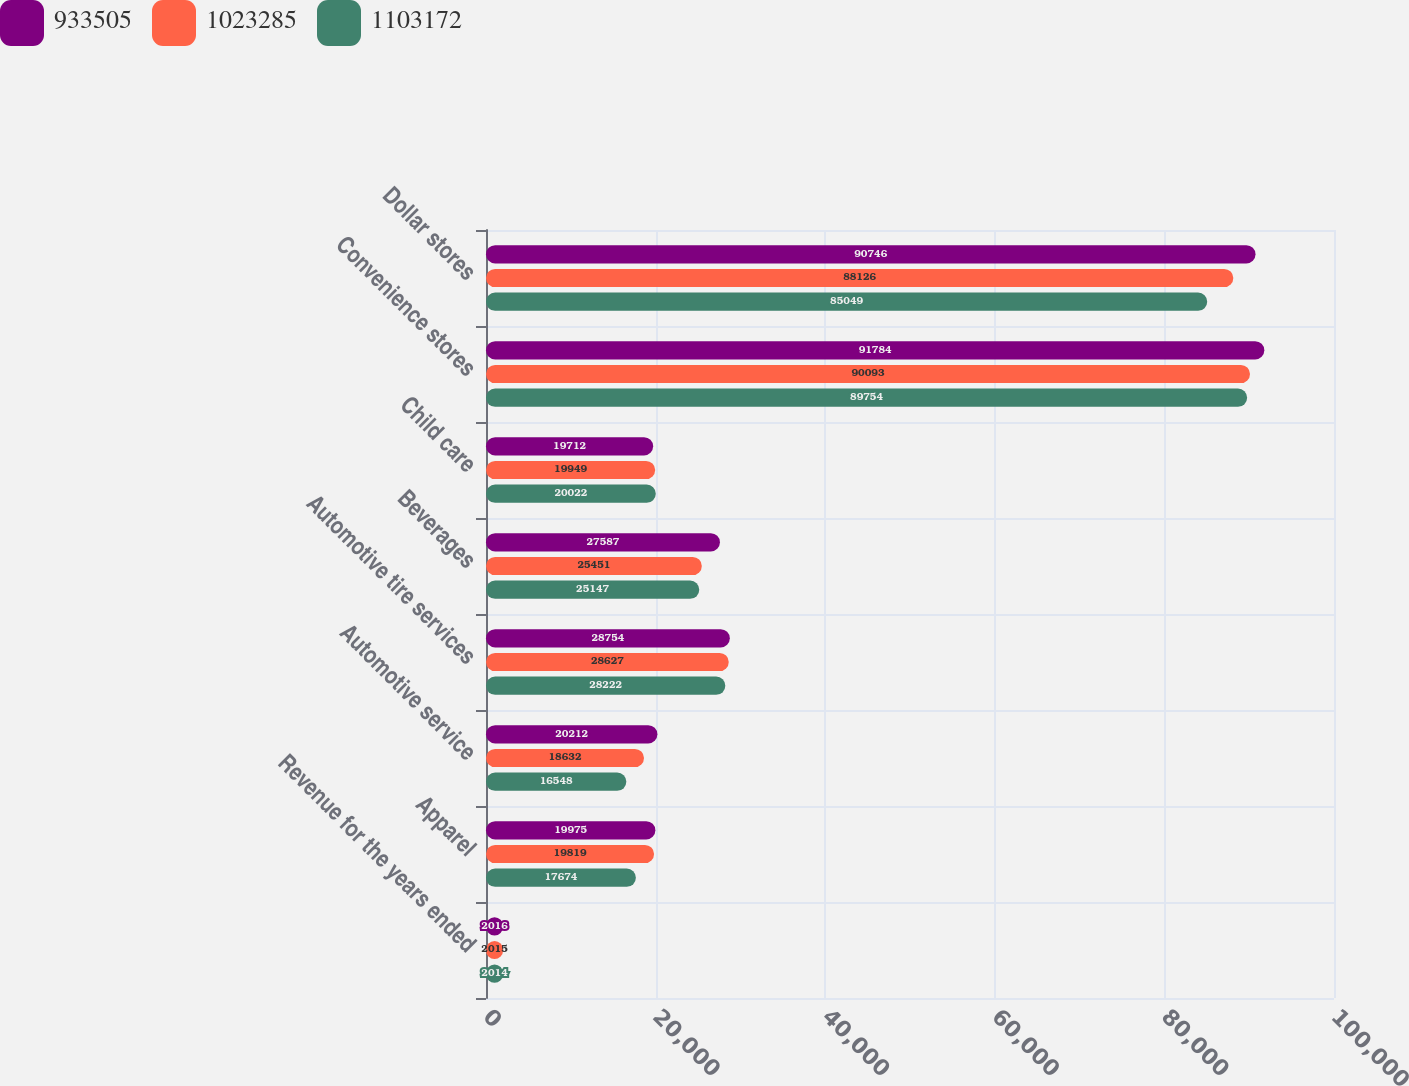Convert chart. <chart><loc_0><loc_0><loc_500><loc_500><stacked_bar_chart><ecel><fcel>Revenue for the years ended<fcel>Apparel<fcel>Automotive service<fcel>Automotive tire services<fcel>Beverages<fcel>Child care<fcel>Convenience stores<fcel>Dollar stores<nl><fcel>933505<fcel>2016<fcel>19975<fcel>20212<fcel>28754<fcel>27587<fcel>19712<fcel>91784<fcel>90746<nl><fcel>1.02328e+06<fcel>2015<fcel>19819<fcel>18632<fcel>28627<fcel>25451<fcel>19949<fcel>90093<fcel>88126<nl><fcel>1.10317e+06<fcel>2014<fcel>17674<fcel>16548<fcel>28222<fcel>25147<fcel>20022<fcel>89754<fcel>85049<nl></chart> 